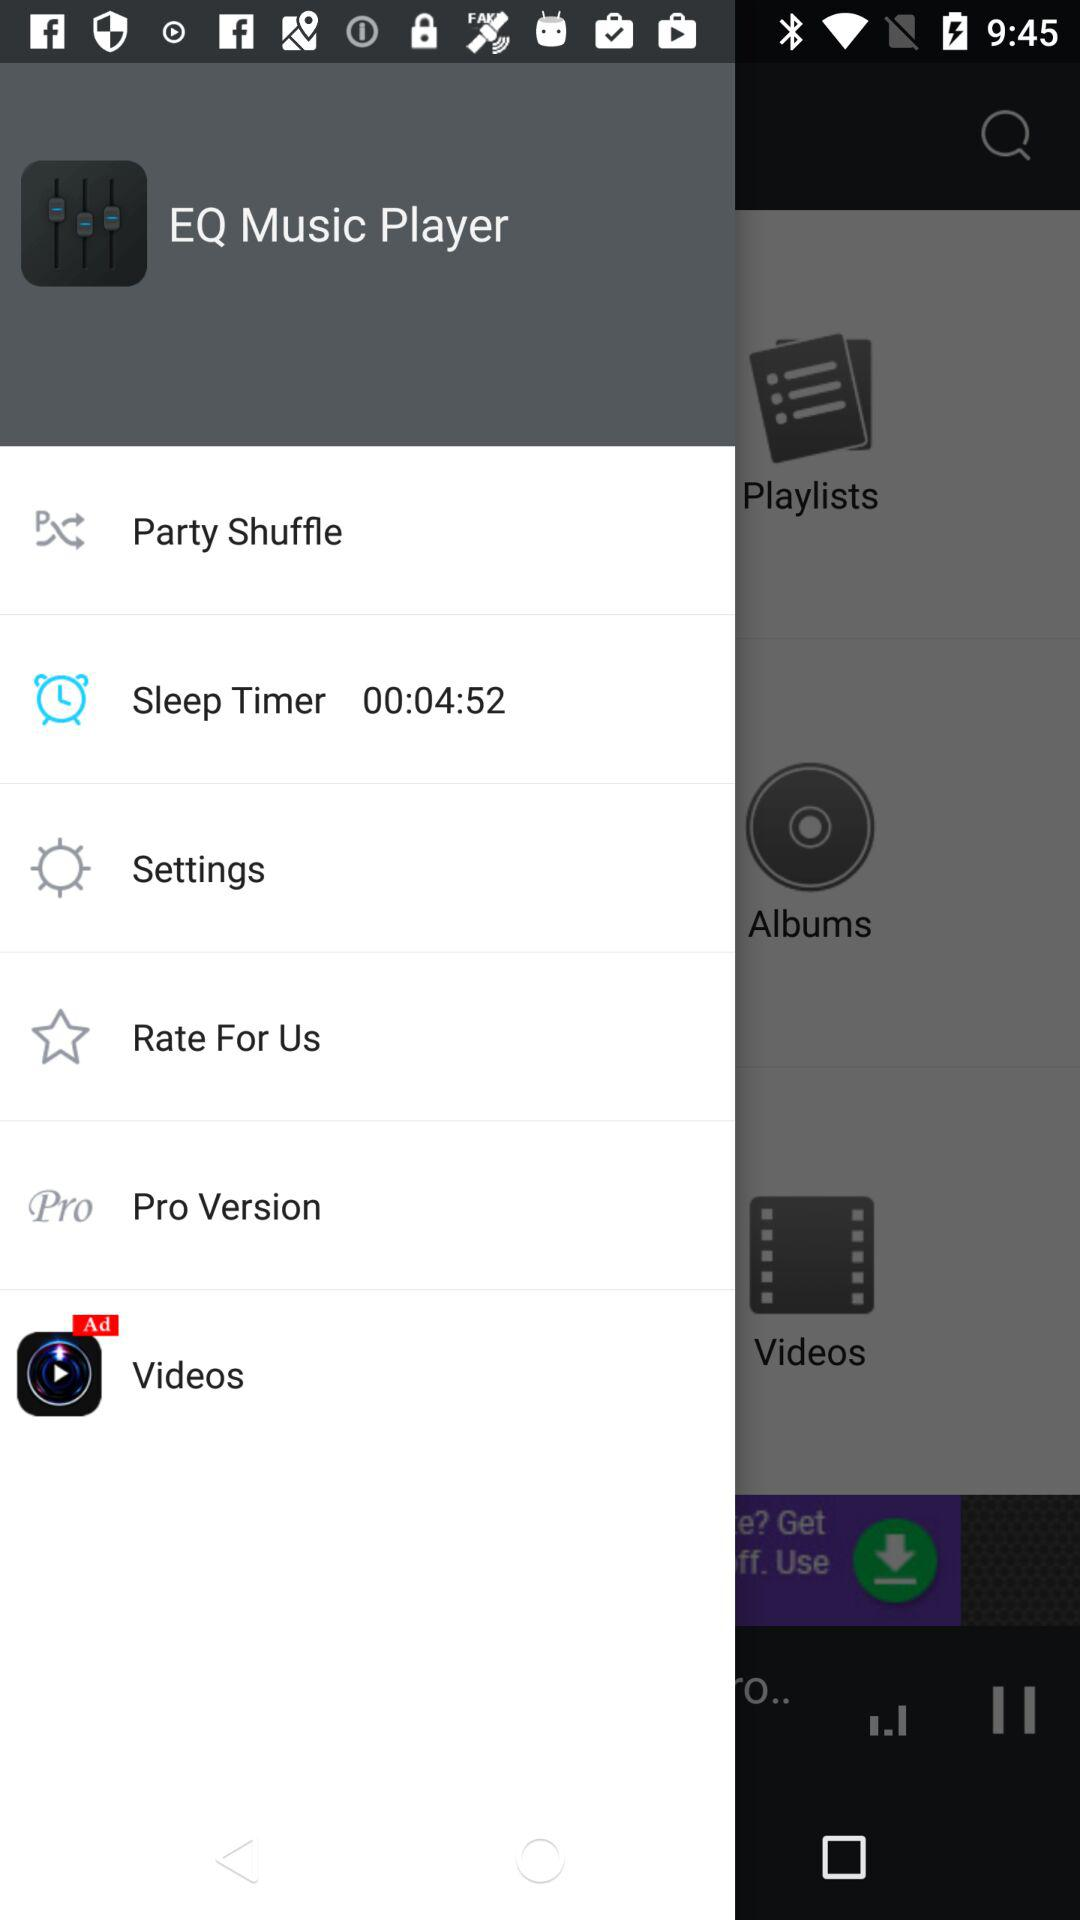How much time is showing on the sleep timer? The time shown on the sleep timer is 00:04:52. 